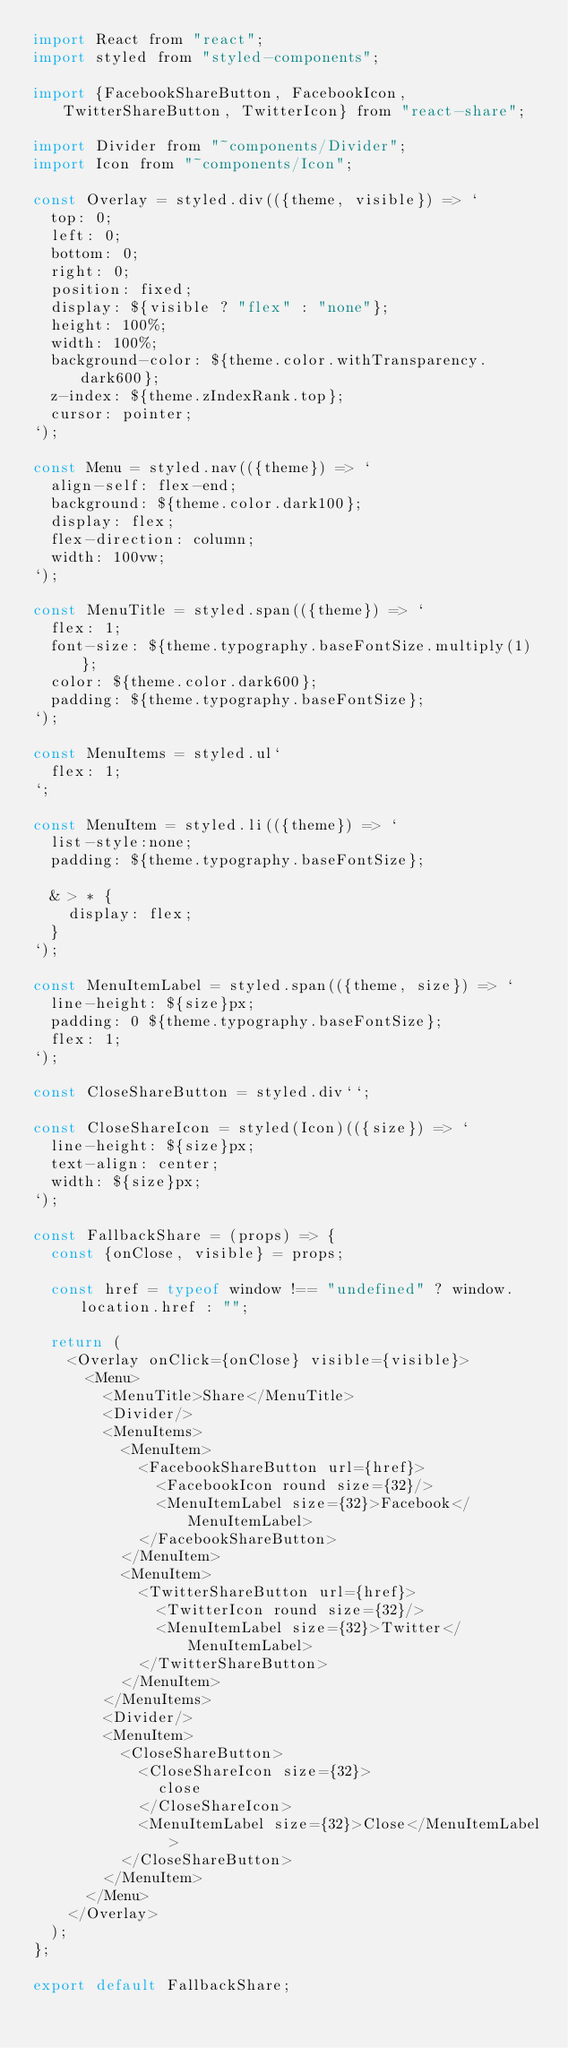<code> <loc_0><loc_0><loc_500><loc_500><_JavaScript_>import React from "react";
import styled from "styled-components";

import {FacebookShareButton, FacebookIcon, TwitterShareButton, TwitterIcon} from "react-share";

import Divider from "~components/Divider";
import Icon from "~components/Icon";

const Overlay = styled.div(({theme, visible}) => `
  top: 0;
  left: 0;
  bottom: 0;
  right: 0;
  position: fixed;
  display: ${visible ? "flex" : "none"};
  height: 100%;
  width: 100%;
  background-color: ${theme.color.withTransparency.dark600};
  z-index: ${theme.zIndexRank.top};
  cursor: pointer;
`);

const Menu = styled.nav(({theme}) => `
  align-self: flex-end;
  background: ${theme.color.dark100};
  display: flex;
  flex-direction: column;
  width: 100vw;
`);

const MenuTitle = styled.span(({theme}) => `
  flex: 1;
  font-size: ${theme.typography.baseFontSize.multiply(1)};
  color: ${theme.color.dark600};
  padding: ${theme.typography.baseFontSize};
`);

const MenuItems = styled.ul`
  flex: 1;
`;

const MenuItem = styled.li(({theme}) => `
  list-style:none;
  padding: ${theme.typography.baseFontSize};
  
  & > * {
    display: flex;
  }
`);

const MenuItemLabel = styled.span(({theme, size}) => `
  line-height: ${size}px;
  padding: 0 ${theme.typography.baseFontSize};
  flex: 1;
`);

const CloseShareButton = styled.div``;

const CloseShareIcon = styled(Icon)(({size}) => `
  line-height: ${size}px;
  text-align: center;
  width: ${size}px;
`);

const FallbackShare = (props) => {
  const {onClose, visible} = props;

  const href = typeof window !== "undefined" ? window.location.href : "";

  return (
    <Overlay onClick={onClose} visible={visible}>
      <Menu>
        <MenuTitle>Share</MenuTitle>
        <Divider/>
        <MenuItems>
          <MenuItem>
            <FacebookShareButton url={href}>
              <FacebookIcon round size={32}/>
              <MenuItemLabel size={32}>Facebook</MenuItemLabel>
            </FacebookShareButton>
          </MenuItem>
          <MenuItem>
            <TwitterShareButton url={href}>
              <TwitterIcon round size={32}/>
              <MenuItemLabel size={32}>Twitter</MenuItemLabel>
            </TwitterShareButton>
          </MenuItem>
        </MenuItems>
        <Divider/>
        <MenuItem>
          <CloseShareButton>
            <CloseShareIcon size={32}>
              close
            </CloseShareIcon>
            <MenuItemLabel size={32}>Close</MenuItemLabel>
          </CloseShareButton>
        </MenuItem>
      </Menu>
    </Overlay>
  );
};

export default FallbackShare;
</code> 